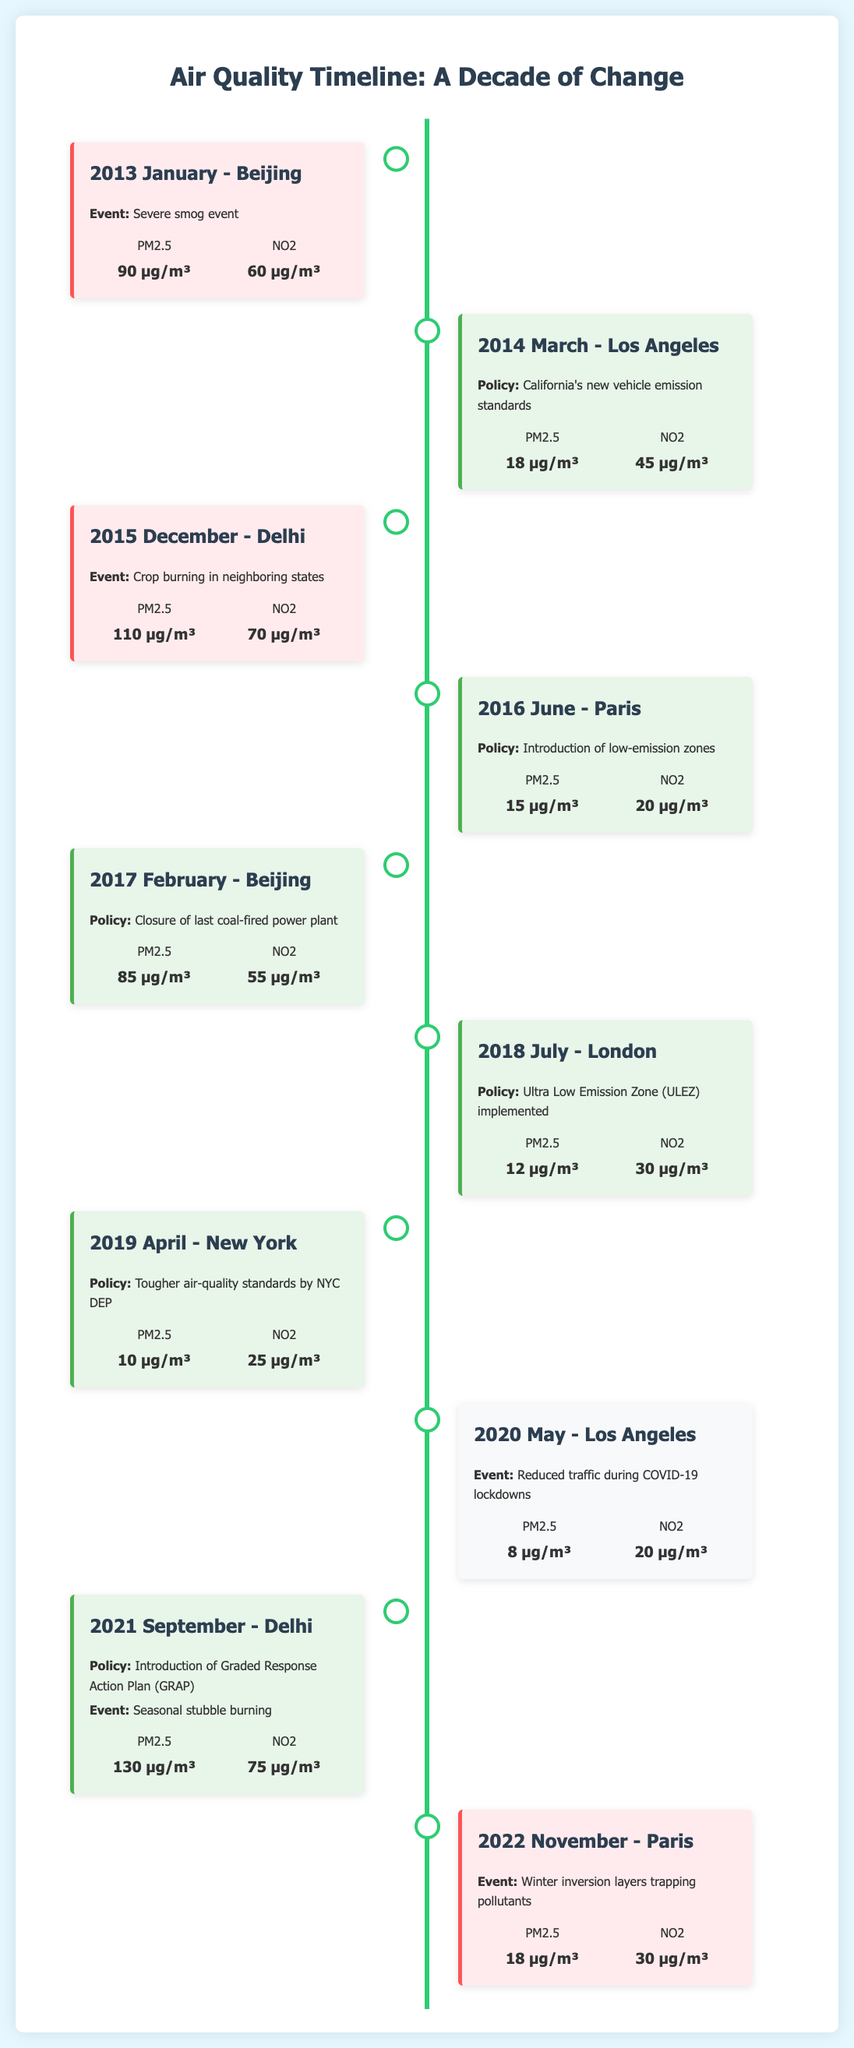what was the PM2.5 level in Beijing in January 2013? The PM2.5 level in Beijing during January 2013 was reported in the peak entry of the timeline.
Answer: 90 µg/m³ what significant policy was introduced in Los Angeles in March 2014? The policy introduced in Los Angeles in March 2014 was California's new vehicle emission standards, as listed in the policy entry.
Answer: California's new vehicle emission standards what event caused high pollution levels in Delhi in December 2015? The event that caused high pollution levels in Delhi during December 2015 was crop burning in neighboring states, mentioned in the peak entry.
Answer: Crop burning which city implemented the Ultra Low Emission Zone (ULEZ) in July 2018? The city that implemented ULEZ in July 2018 is found in the policy entry of the timeline.
Answer: London what is the peak PM2.5 level recorded in Delhi in September 2021? The peak PM2.5 level recorded in Delhi in September 2021 is reflected in the combined entry of policy and peak events.
Answer: 130 µg/m³ how did air quality change in Los Angeles in May 2020? In May 2020, Los Angeles experienced reduced traffic due to COVID-19 lockdowns, which is noted in the event entry.
Answer: Reduced traffic which policy was introduced in Paris in June 2016? The policy introduced in Paris in June 2016 is specified in the timeline's entry for that month.
Answer: Introduction of low-emission zones what caused the peak in pollution levels in Paris in November 2022? The peak in pollution levels in Paris in November 2022 was due to winter inversion layers trapping pollutants, indicated in the peak entry.
Answer: Winter inversion layers trapping pollutants what is the NO2 level recorded in New York in April 2019? The NO2 level in New York for April 2019 can be found in the associated policy entry.
Answer: 25 µg/m³ 